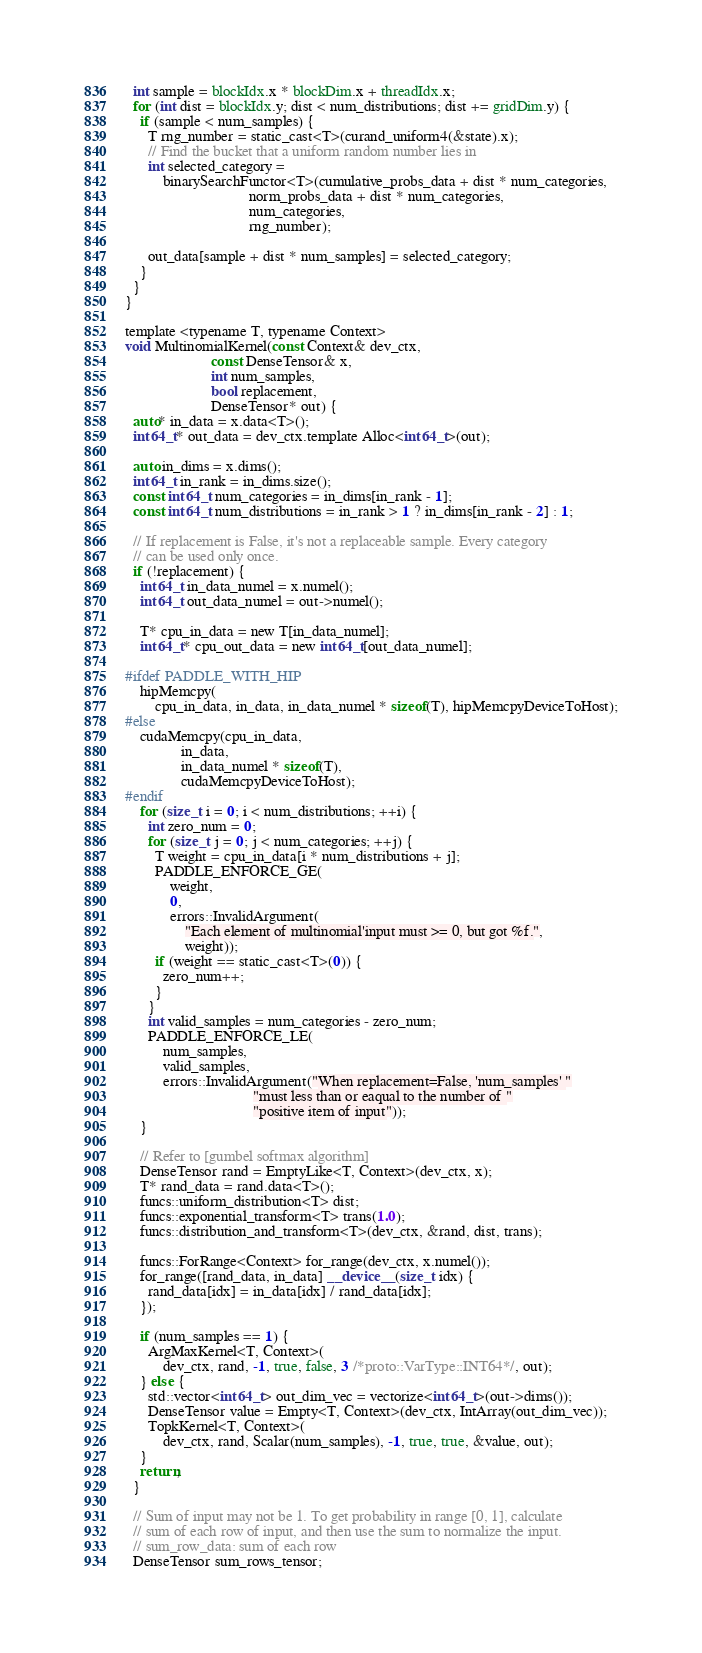<code> <loc_0><loc_0><loc_500><loc_500><_Cuda_>
  int sample = blockIdx.x * blockDim.x + threadIdx.x;
  for (int dist = blockIdx.y; dist < num_distributions; dist += gridDim.y) {
    if (sample < num_samples) {
      T rng_number = static_cast<T>(curand_uniform4(&state).x);
      // Find the bucket that a uniform random number lies in
      int selected_category =
          binarySearchFunctor<T>(cumulative_probs_data + dist * num_categories,
                                 norm_probs_data + dist * num_categories,
                                 num_categories,
                                 rng_number);

      out_data[sample + dist * num_samples] = selected_category;
    }
  }
}

template <typename T, typename Context>
void MultinomialKernel(const Context& dev_ctx,
                       const DenseTensor& x,
                       int num_samples,
                       bool replacement,
                       DenseTensor* out) {
  auto* in_data = x.data<T>();
  int64_t* out_data = dev_ctx.template Alloc<int64_t>(out);

  auto in_dims = x.dims();
  int64_t in_rank = in_dims.size();
  const int64_t num_categories = in_dims[in_rank - 1];
  const int64_t num_distributions = in_rank > 1 ? in_dims[in_rank - 2] : 1;

  // If replacement is False, it's not a replaceable sample. Every category
  // can be used only once.
  if (!replacement) {
    int64_t in_data_numel = x.numel();
    int64_t out_data_numel = out->numel();

    T* cpu_in_data = new T[in_data_numel];
    int64_t* cpu_out_data = new int64_t[out_data_numel];

#ifdef PADDLE_WITH_HIP
    hipMemcpy(
        cpu_in_data, in_data, in_data_numel * sizeof(T), hipMemcpyDeviceToHost);
#else
    cudaMemcpy(cpu_in_data,
               in_data,
               in_data_numel * sizeof(T),
               cudaMemcpyDeviceToHost);
#endif
    for (size_t i = 0; i < num_distributions; ++i) {
      int zero_num = 0;
      for (size_t j = 0; j < num_categories; ++j) {
        T weight = cpu_in_data[i * num_distributions + j];
        PADDLE_ENFORCE_GE(
            weight,
            0,
            errors::InvalidArgument(
                "Each element of multinomial'input must >= 0, but got %f.",
                weight));
        if (weight == static_cast<T>(0)) {
          zero_num++;
        }
      }
      int valid_samples = num_categories - zero_num;
      PADDLE_ENFORCE_LE(
          num_samples,
          valid_samples,
          errors::InvalidArgument("When replacement=False, 'num_samples' "
                                  "must less than or eaqual to the number of "
                                  "positive item of input"));
    }

    // Refer to [gumbel softmax algorithm]
    DenseTensor rand = EmptyLike<T, Context>(dev_ctx, x);
    T* rand_data = rand.data<T>();
    funcs::uniform_distribution<T> dist;
    funcs::exponential_transform<T> trans(1.0);
    funcs::distribution_and_transform<T>(dev_ctx, &rand, dist, trans);

    funcs::ForRange<Context> for_range(dev_ctx, x.numel());
    for_range([rand_data, in_data] __device__(size_t idx) {
      rand_data[idx] = in_data[idx] / rand_data[idx];
    });

    if (num_samples == 1) {
      ArgMaxKernel<T, Context>(
          dev_ctx, rand, -1, true, false, 3 /*proto::VarType::INT64*/, out);
    } else {
      std::vector<int64_t> out_dim_vec = vectorize<int64_t>(out->dims());
      DenseTensor value = Empty<T, Context>(dev_ctx, IntArray(out_dim_vec));
      TopkKernel<T, Context>(
          dev_ctx, rand, Scalar(num_samples), -1, true, true, &value, out);
    }
    return;
  }

  // Sum of input may not be 1. To get probability in range [0, 1], calculate
  // sum of each row of input, and then use the sum to normalize the input.
  // sum_row_data: sum of each row
  DenseTensor sum_rows_tensor;</code> 